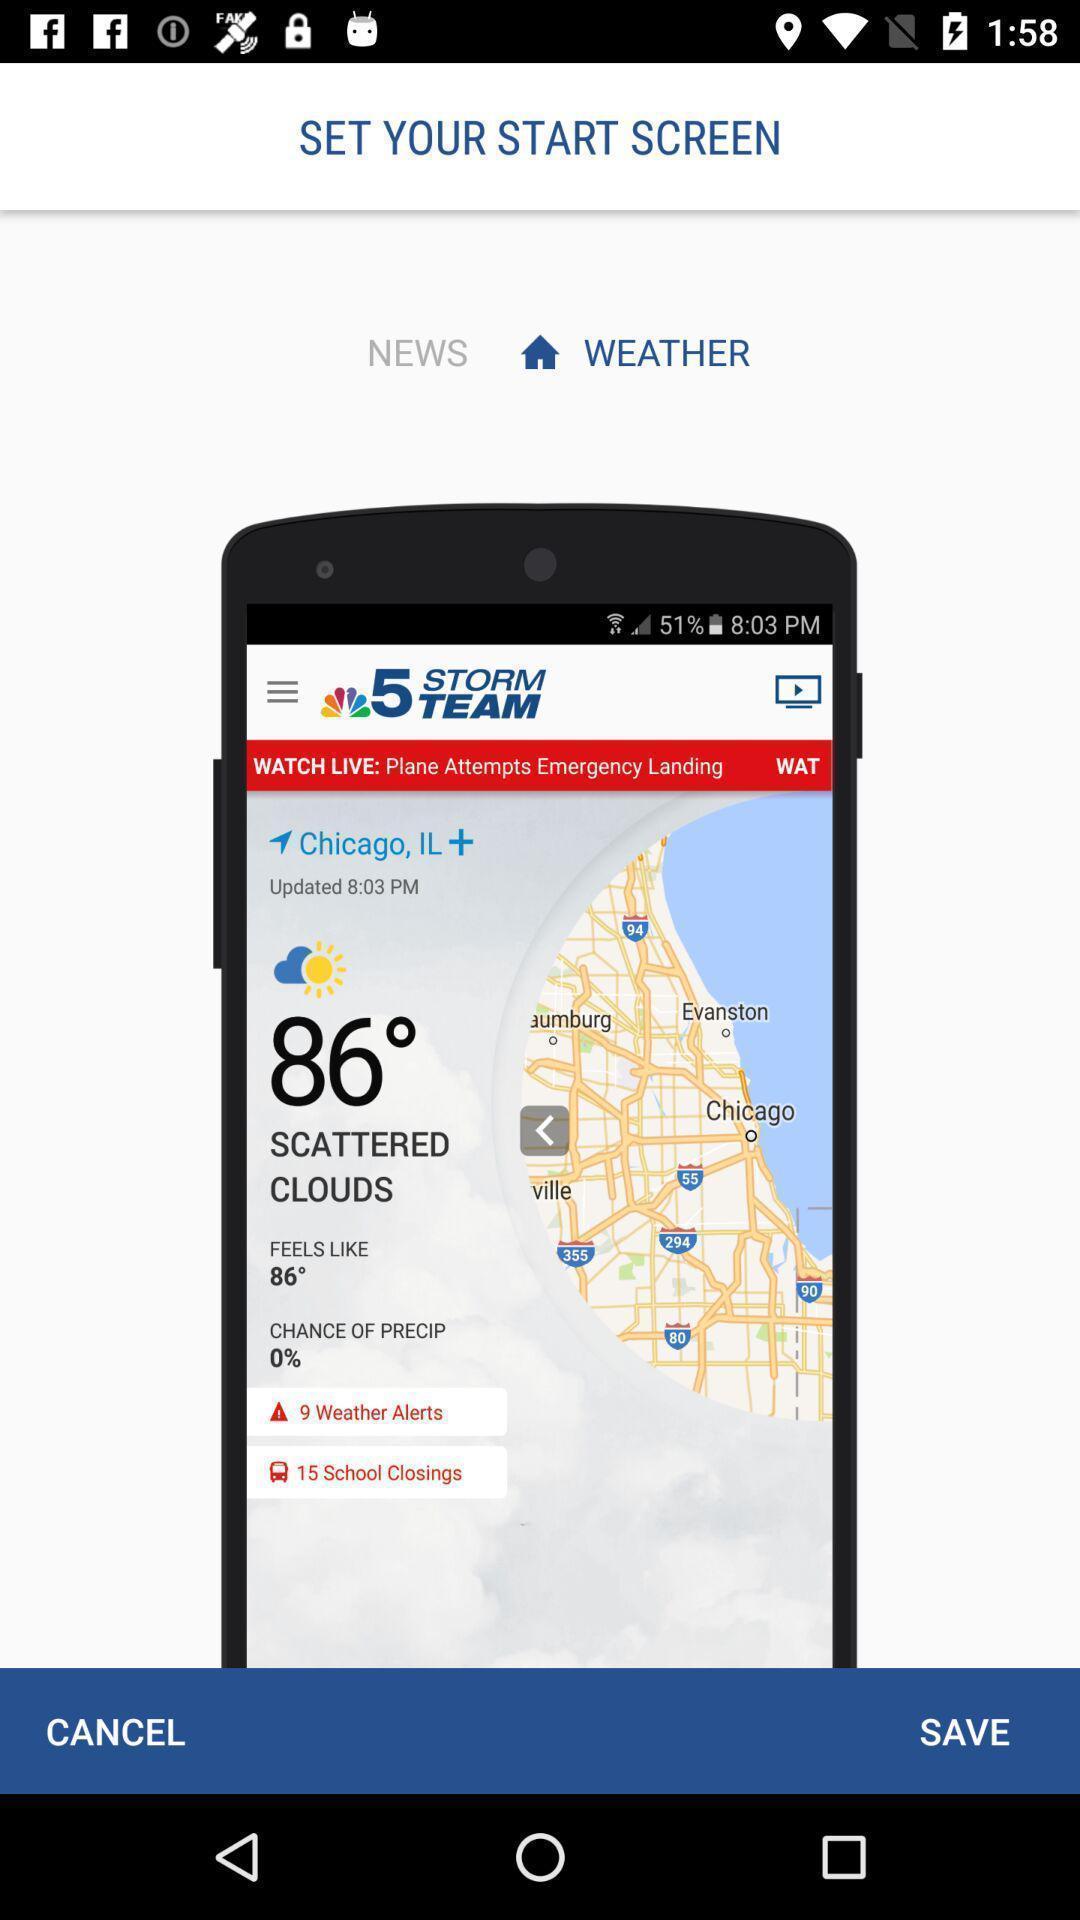Please provide a description for this image. Screen shows to start screen. 